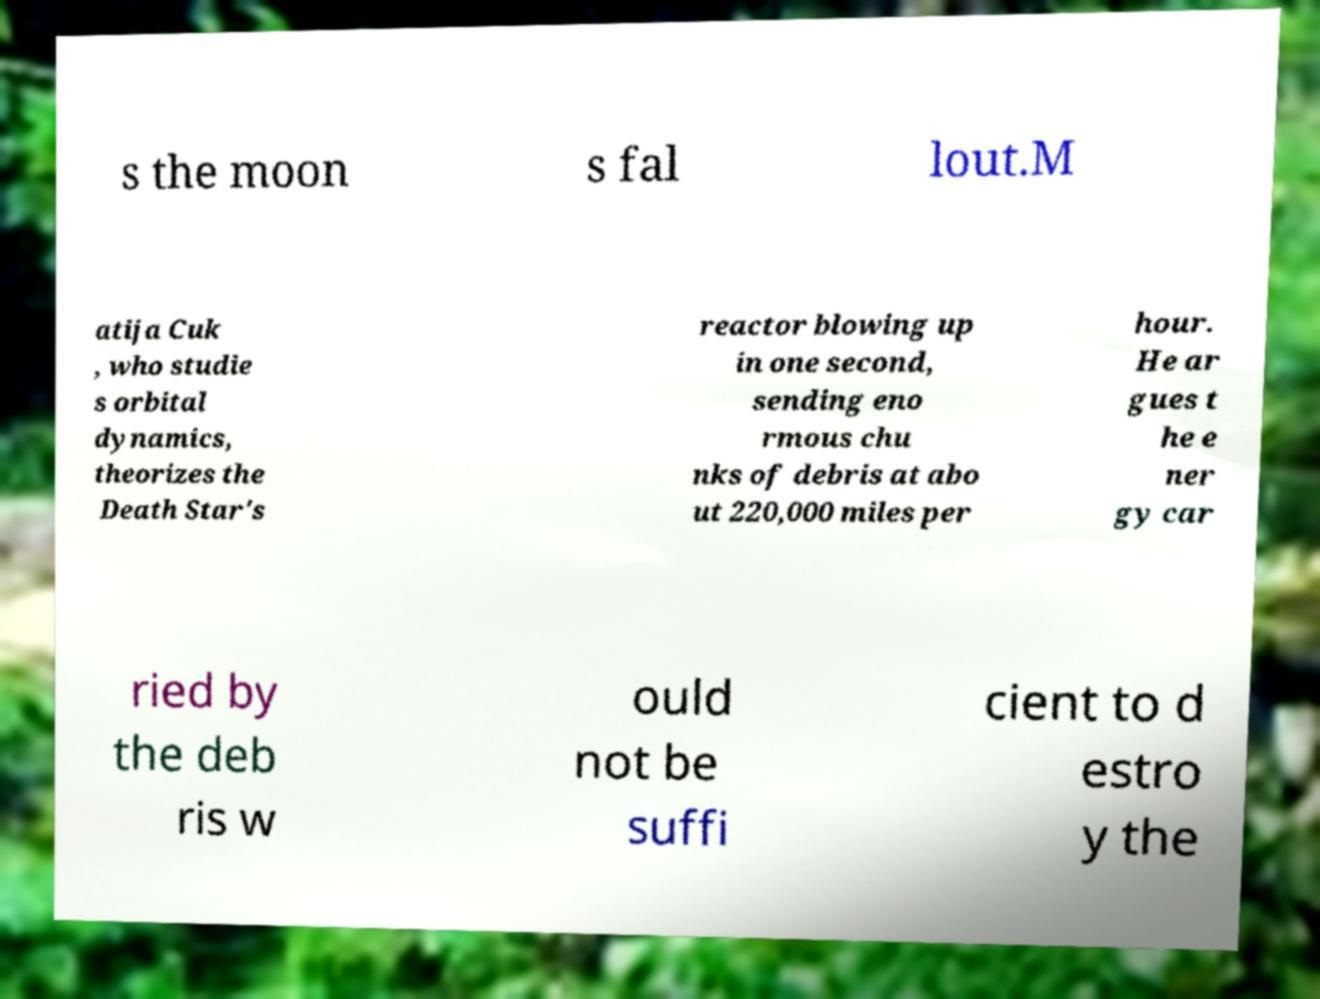There's text embedded in this image that I need extracted. Can you transcribe it verbatim? s the moon s fal lout.M atija Cuk , who studie s orbital dynamics, theorizes the Death Star's reactor blowing up in one second, sending eno rmous chu nks of debris at abo ut 220,000 miles per hour. He ar gues t he e ner gy car ried by the deb ris w ould not be suffi cient to d estro y the 